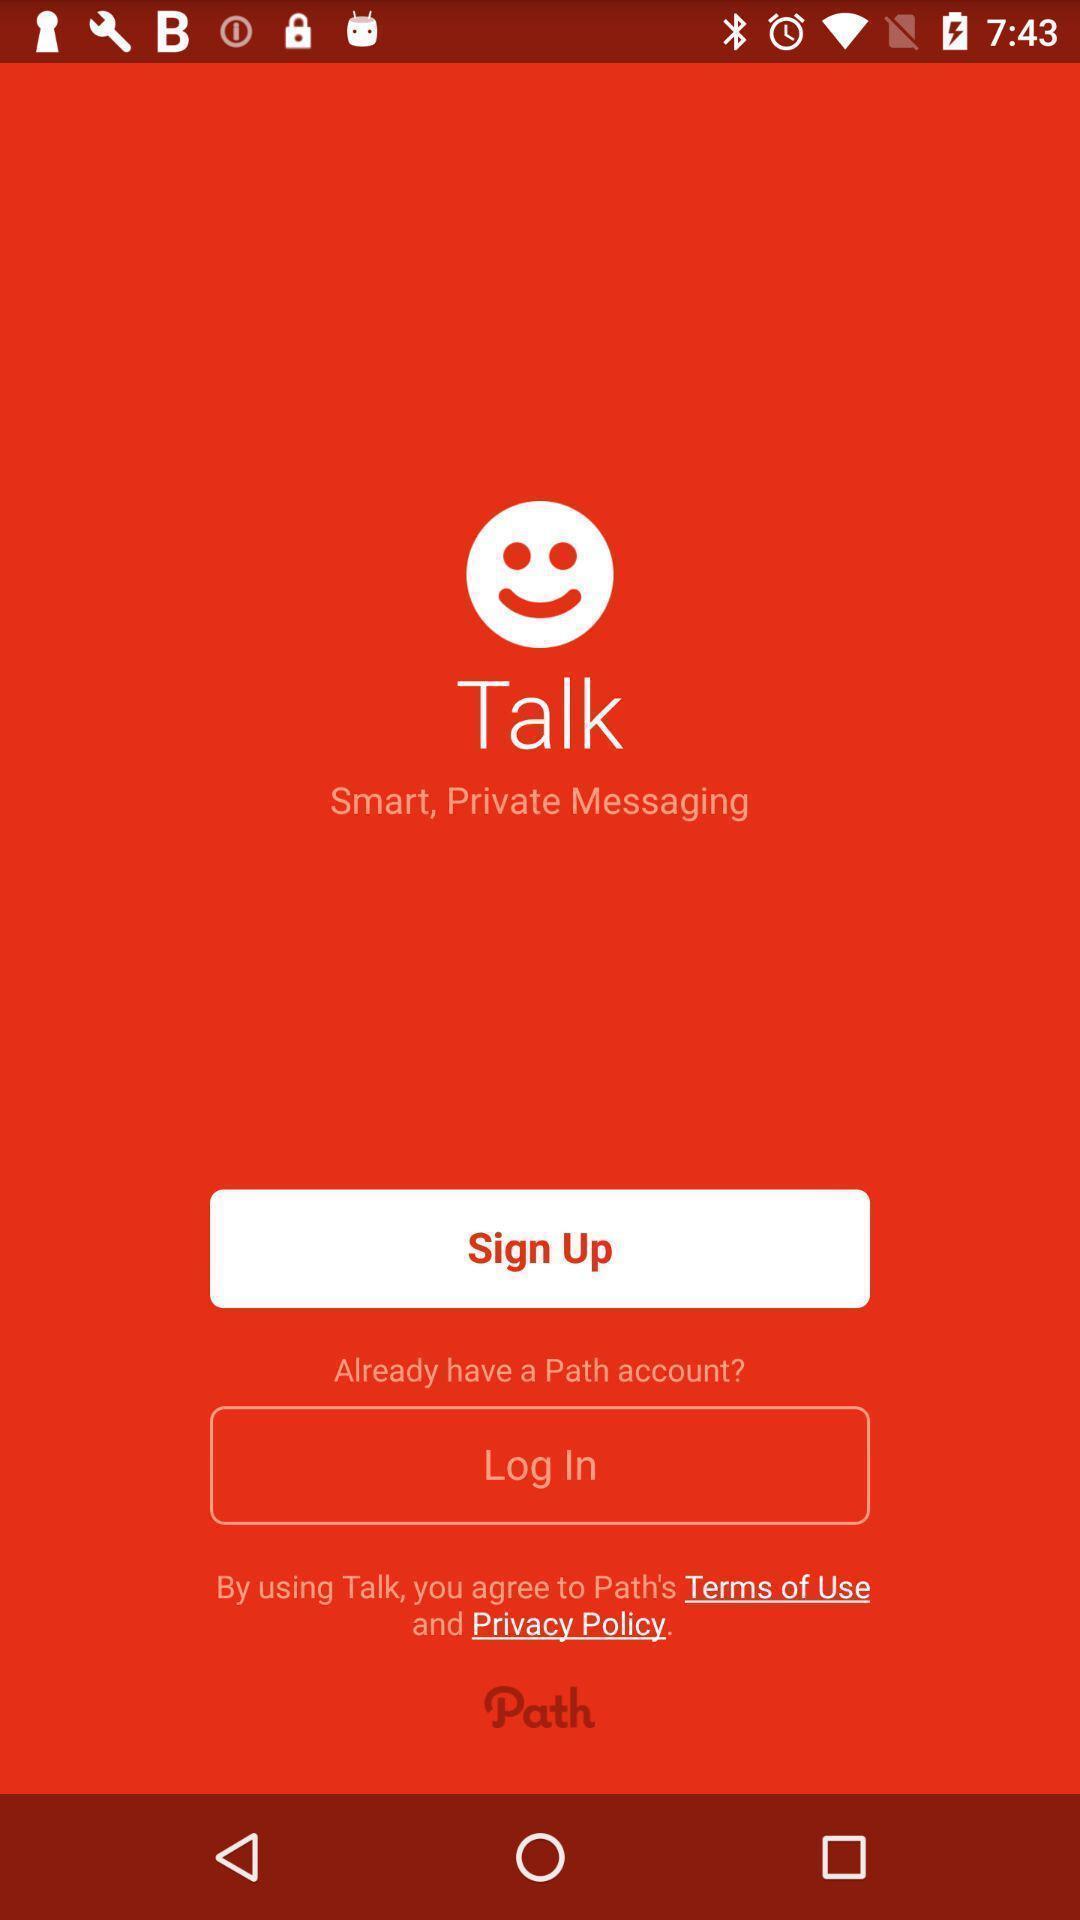Describe the content in this image. Welcome page. 